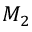<formula> <loc_0><loc_0><loc_500><loc_500>M _ { 2 }</formula> 